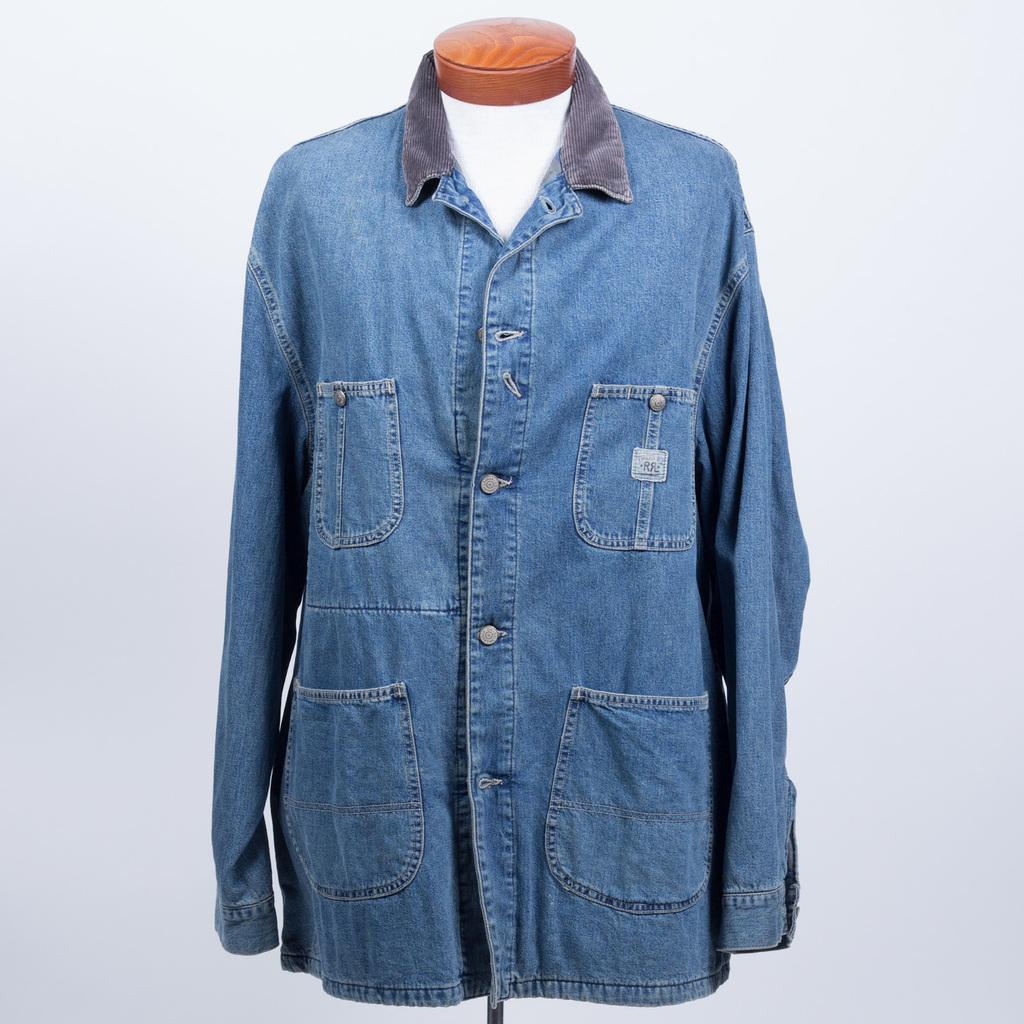What is the main subject of the image? There is a denim shirt in the center of the image. What type of seed is growing in the denim shirt in the image? There is no seed or plant growing in the denim shirt in the image. What kind of pie is being served on the denim shirt in the image? There is no pie or food present on the denim shirt in the image. 